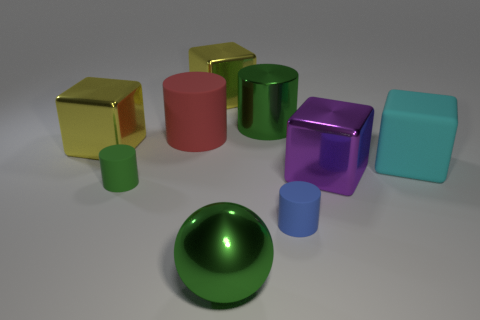Are there more matte objects behind the blue cylinder than small green objects?
Your answer should be compact. Yes. What shape is the big matte object on the right side of the green shiny object that is in front of the big object that is left of the small green matte thing?
Offer a terse response. Cube. Is the size of the green cylinder that is on the left side of the red rubber object the same as the red cylinder?
Your response must be concise. No. What is the shape of the large shiny object that is both to the right of the big green ball and behind the cyan rubber object?
Your answer should be very brief. Cylinder. Do the sphere and the large cylinder that is behind the large rubber cylinder have the same color?
Offer a very short reply. Yes. The tiny matte thing on the right side of the green cylinder that is in front of the cyan thing that is behind the green metal sphere is what color?
Give a very brief answer. Blue. The other big metallic thing that is the same shape as the red object is what color?
Keep it short and to the point. Green. Are there an equal number of large purple things to the left of the ball and gray balls?
Make the answer very short. Yes. How many cubes are either tiny matte things or yellow metallic objects?
Your response must be concise. 2. What color is the other big thing that is made of the same material as the large red object?
Provide a succinct answer. Cyan. 